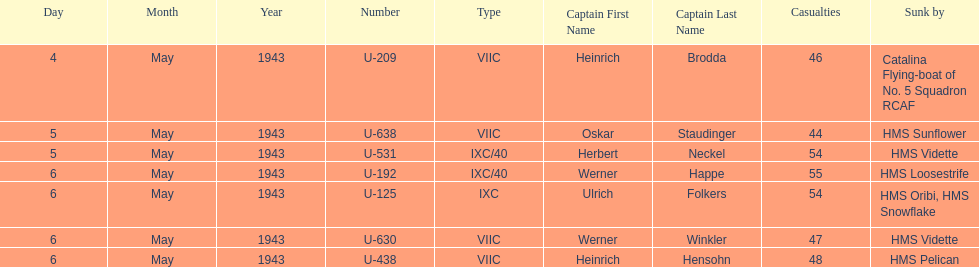Aside from oskar staudinger what was the name of the other captain of the u-boat loast on may 5? Herbert Neckel. 